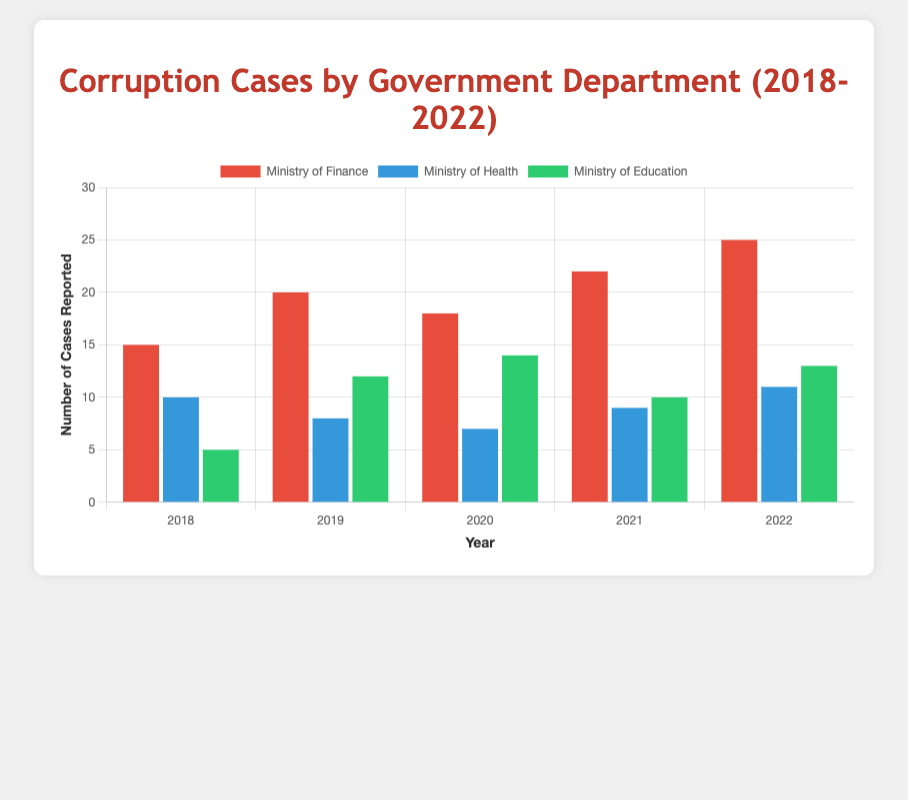Which year saw the highest number of corruption cases reported in the Ministry of Finance? Observing the bar heights for the Ministry of Finance over the years, 2022 has the tallest bar, indicating the highest number of corruption cases reported.
Answer: 2022 How did the number of corruption cases in the Ministry of Health change from 2018 to 2022? Check the bars for the Ministry of Health in both 2018 and 2022. In 2018 the number was 10, and in 2022 it increased to 11, showing a slight increase.
Answer: Increased by 1 What is the total number of corruption cases reported in the Ministry of Education across all years? Sum the values for the Ministry of Education from each year: 5 (2018) + 12 (2019) + 14 (2020) + 10 (2021) + 13 (2022). The sum is 54.
Answer: 54 Which government department reported the least corruption cases in 2019? Compare the bar heights for all departments in 2019. The Ministry of Health has the shortest bar with 8 cases.
Answer: Ministry of Health In 2021, how many more cases were reported by the Ministry of Finance compared to the Ministry of Education? Subtract the number of cases for the Ministry of Education from those for the Ministry of Finance in 2021: 22 - 10 = 12.
Answer: 12 Which year had the least total number of corruption cases reported across all departments? Sum the cases for each year and compare: 
2018: 15+10+5 = 30 
2019: 20+8+12 = 40 
2020: 18+7+14 = 39 
2021: 22+9+10 = 41 
2022: 25+11+13 = 49. 
2018 has the lowest total at 30.
Answer: 2018 What is the average number of corruption cases reported per year by the Ministry of Health? Sum the cases for the Ministry of Health across all years and divide by the number of years: (10 + 8 + 7 + 9 + 11)/5 = 9.
Answer: 9 Did the Ministry of Education see a higher number of cases reported in 2020 compared to 2019? Compare the number of cases reported in 2019 (12) with 2020 (14). Since 14 is greater than 12, the answer is yes.
Answer: Yes How did the number of corruption cases reported by the Ministry of Finance in 2020 compare to 2018? Subtract the number of cases in 2018 from those in 2020: 18 - 15 = 3 more cases in 2020.
Answer: 3 more 